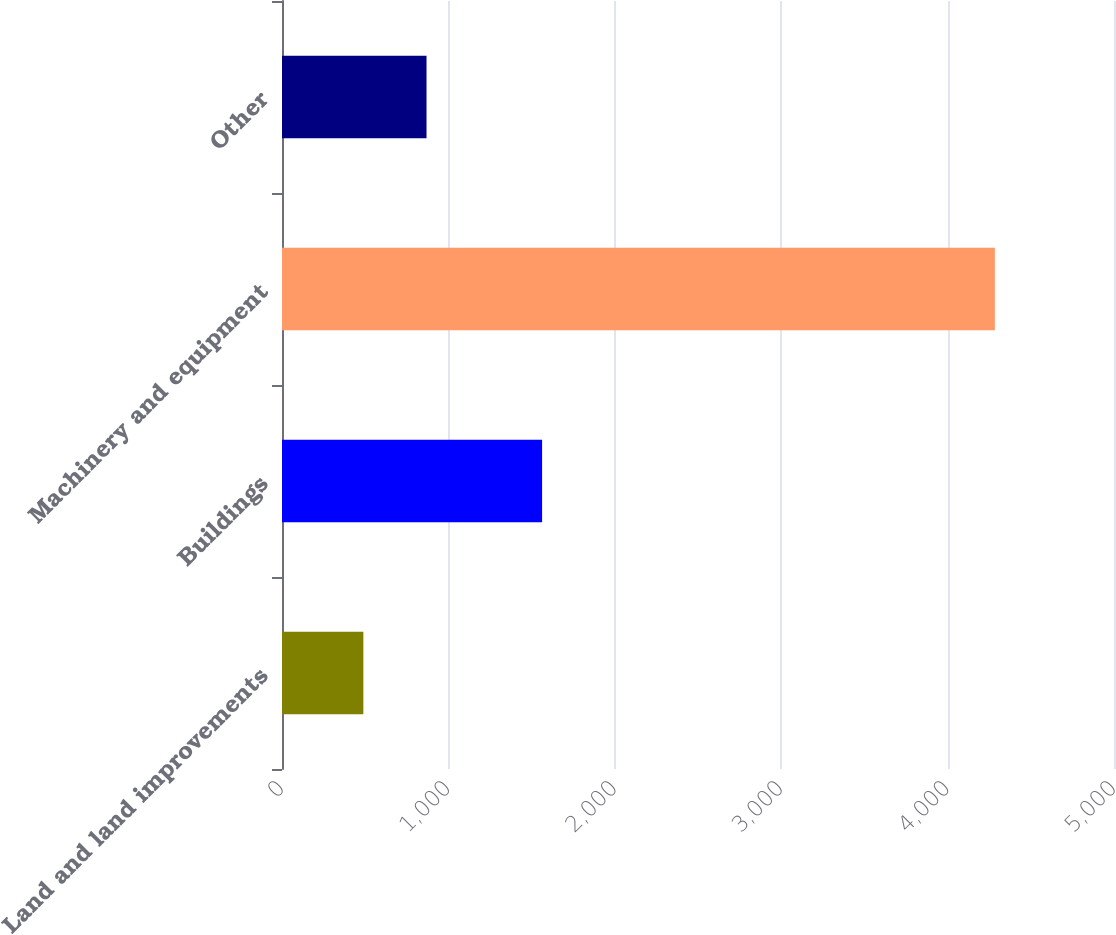<chart> <loc_0><loc_0><loc_500><loc_500><bar_chart><fcel>Land and land improvements<fcel>Buildings<fcel>Machinery and equipment<fcel>Other<nl><fcel>489<fcel>1563<fcel>4284<fcel>868.5<nl></chart> 